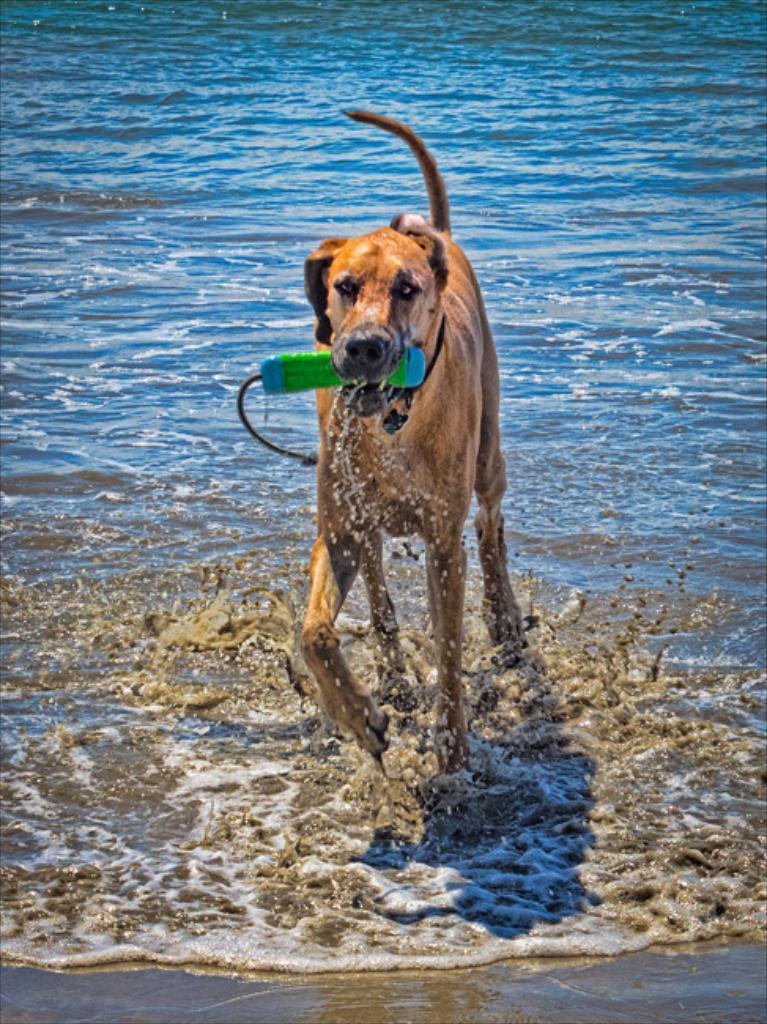Could you give a brief overview of what you see in this image? In this picture there is a dog who is holding green bottle in his mouth. In the back we can see water. 